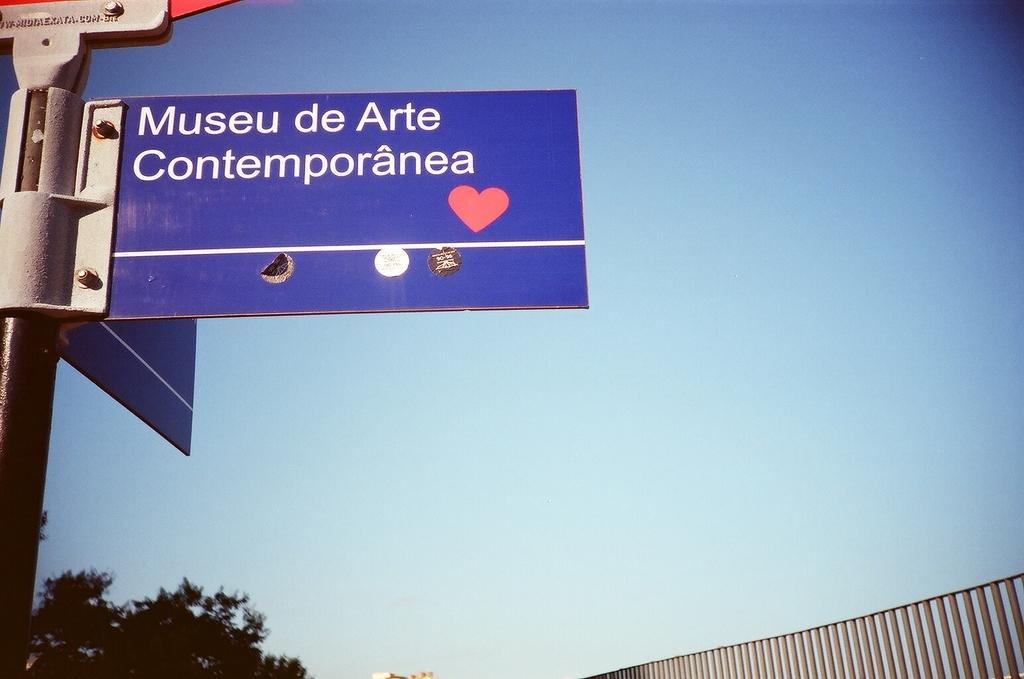<image>
Render a clear and concise summary of the photo. A sign points towards a contemporary arts museum. 